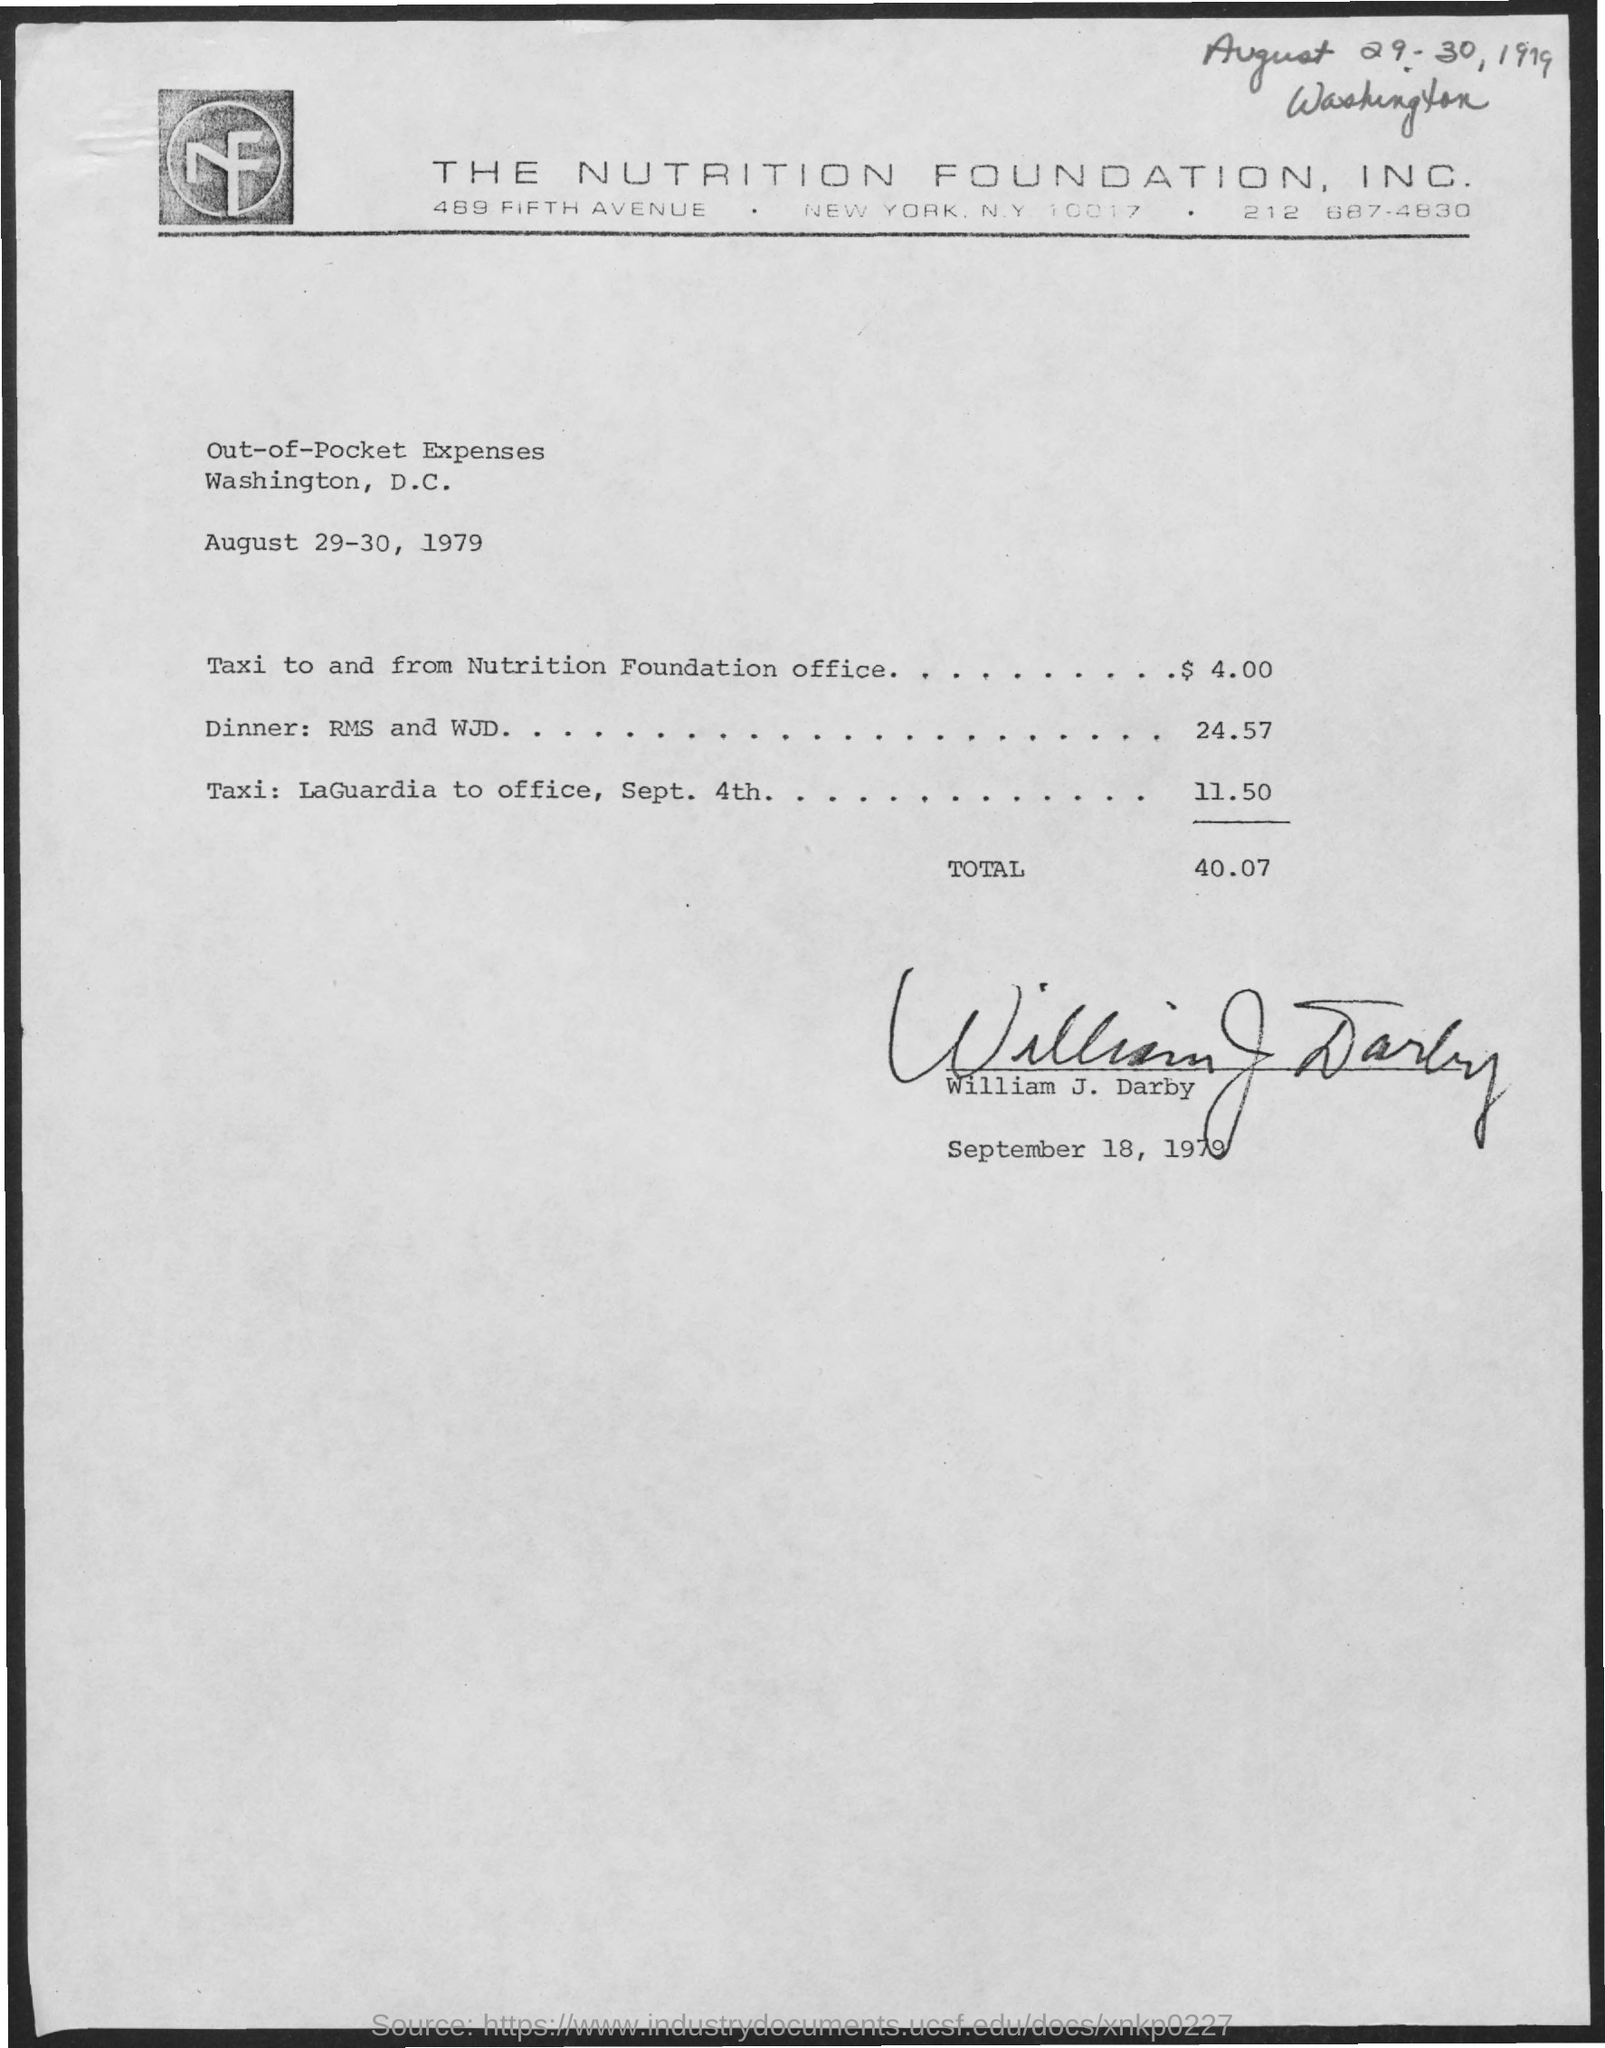Which company is mentioned in the header of the document?
Keep it short and to the point. The Nutrition Foundation, Inc. Who has signed this document?
Provide a short and direct response. William J. Darby. 